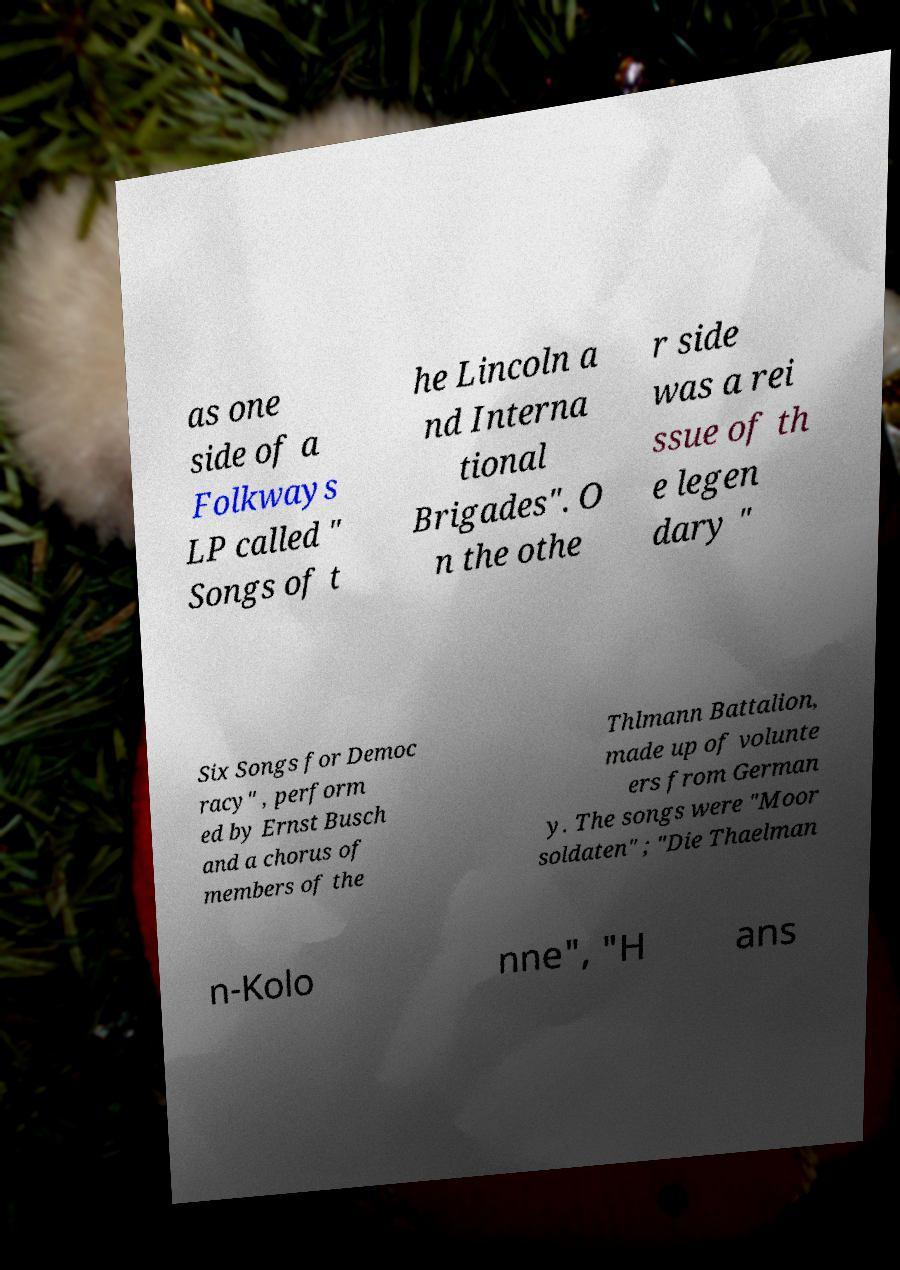There's text embedded in this image that I need extracted. Can you transcribe it verbatim? as one side of a Folkways LP called " Songs of t he Lincoln a nd Interna tional Brigades". O n the othe r side was a rei ssue of th e legen dary " Six Songs for Democ racy" , perform ed by Ernst Busch and a chorus of members of the Thlmann Battalion, made up of volunte ers from German y. The songs were "Moor soldaten" ; "Die Thaelman n-Kolo nne", "H ans 